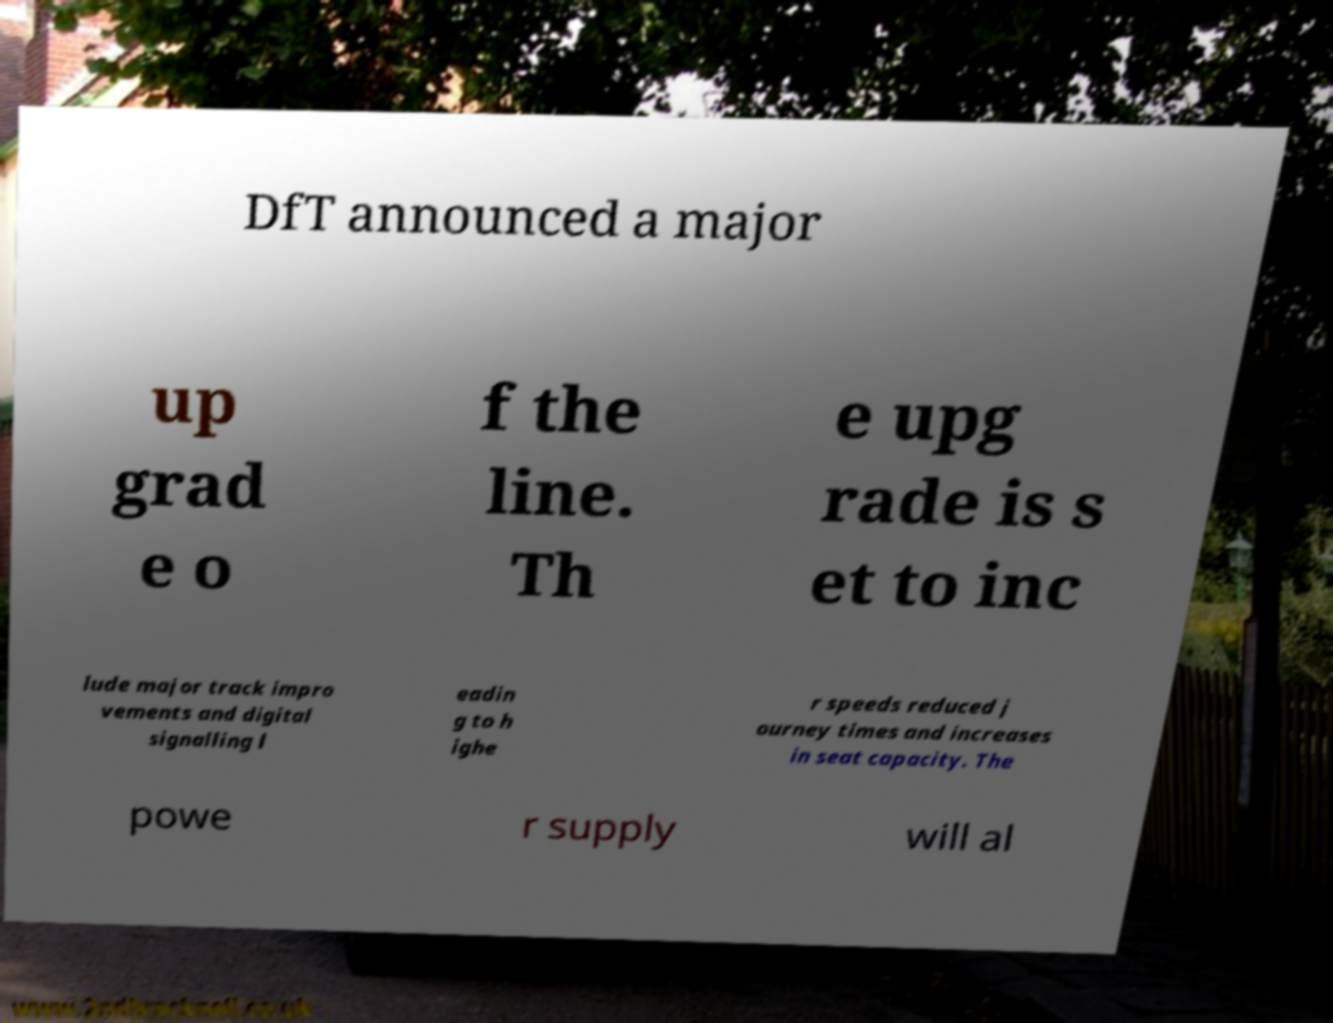There's text embedded in this image that I need extracted. Can you transcribe it verbatim? DfT announced a major up grad e o f the line. Th e upg rade is s et to inc lude major track impro vements and digital signalling l eadin g to h ighe r speeds reduced j ourney times and increases in seat capacity. The powe r supply will al 